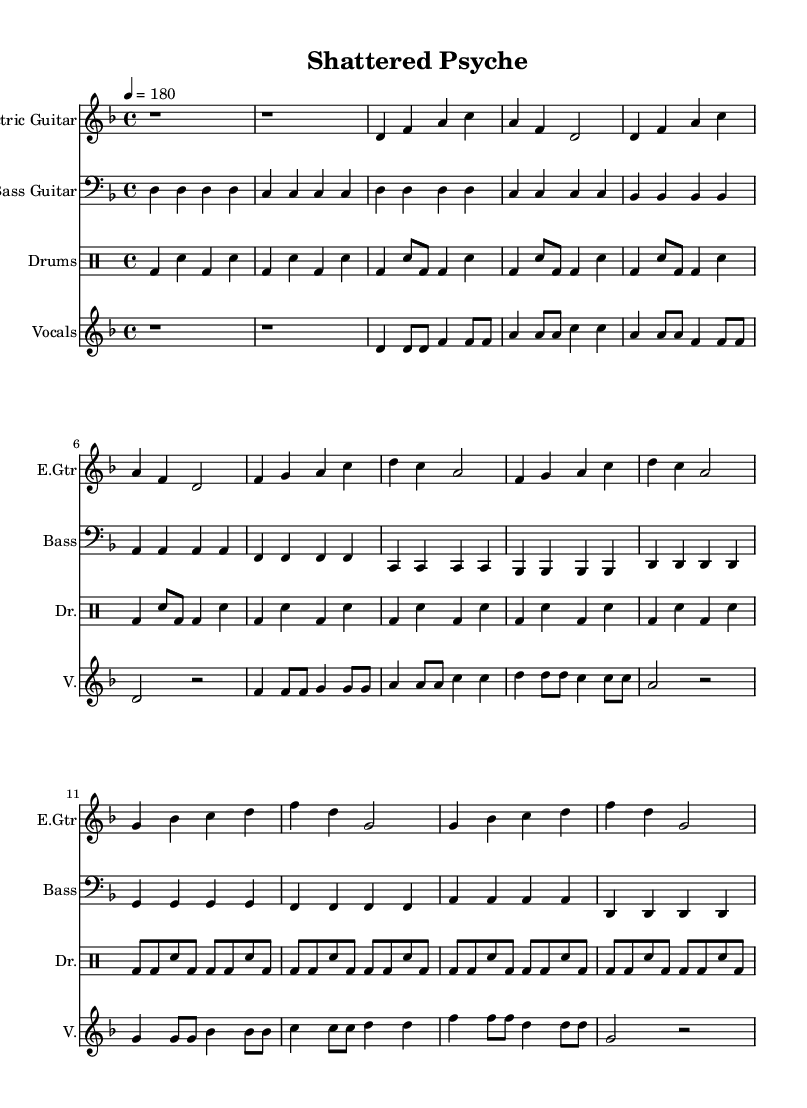What is the key signature of this music? The key signature is D minor, which has one flat (B flat).
Answer: D minor What is the time signature of this music? The time signature is 4/4, indicating four beats in each measure.
Answer: 4/4 What is the tempo marking? The tempo marking is 180 beats per minute, suggesting a fast pace typical of punk music.
Answer: 180 How many measures are in the chorus? The chorus contains 4 measures, as counted from the repeat of the chorus section.
Answer: 4 measures Which instruments are used in this piece? The piece includes Electric Guitar, Bass Guitar, Drums, and Vocals, all labeled in the music.
Answer: Electric Guitar, Bass Guitar, Drums, Vocals What is the dynamic range indicated for the vocal part? The vocal part does not have specific dynamic markings, which may suggest a consistent intensity as common in hardcore punk.
Answer: No specific dynamics How is the structure of the song organized? The structure follows a common punk format of Intro, Verse, Chorus, and Bridge, showing a typical arrangement in punk music.
Answer: Intro, Verse, Chorus, Bridge 